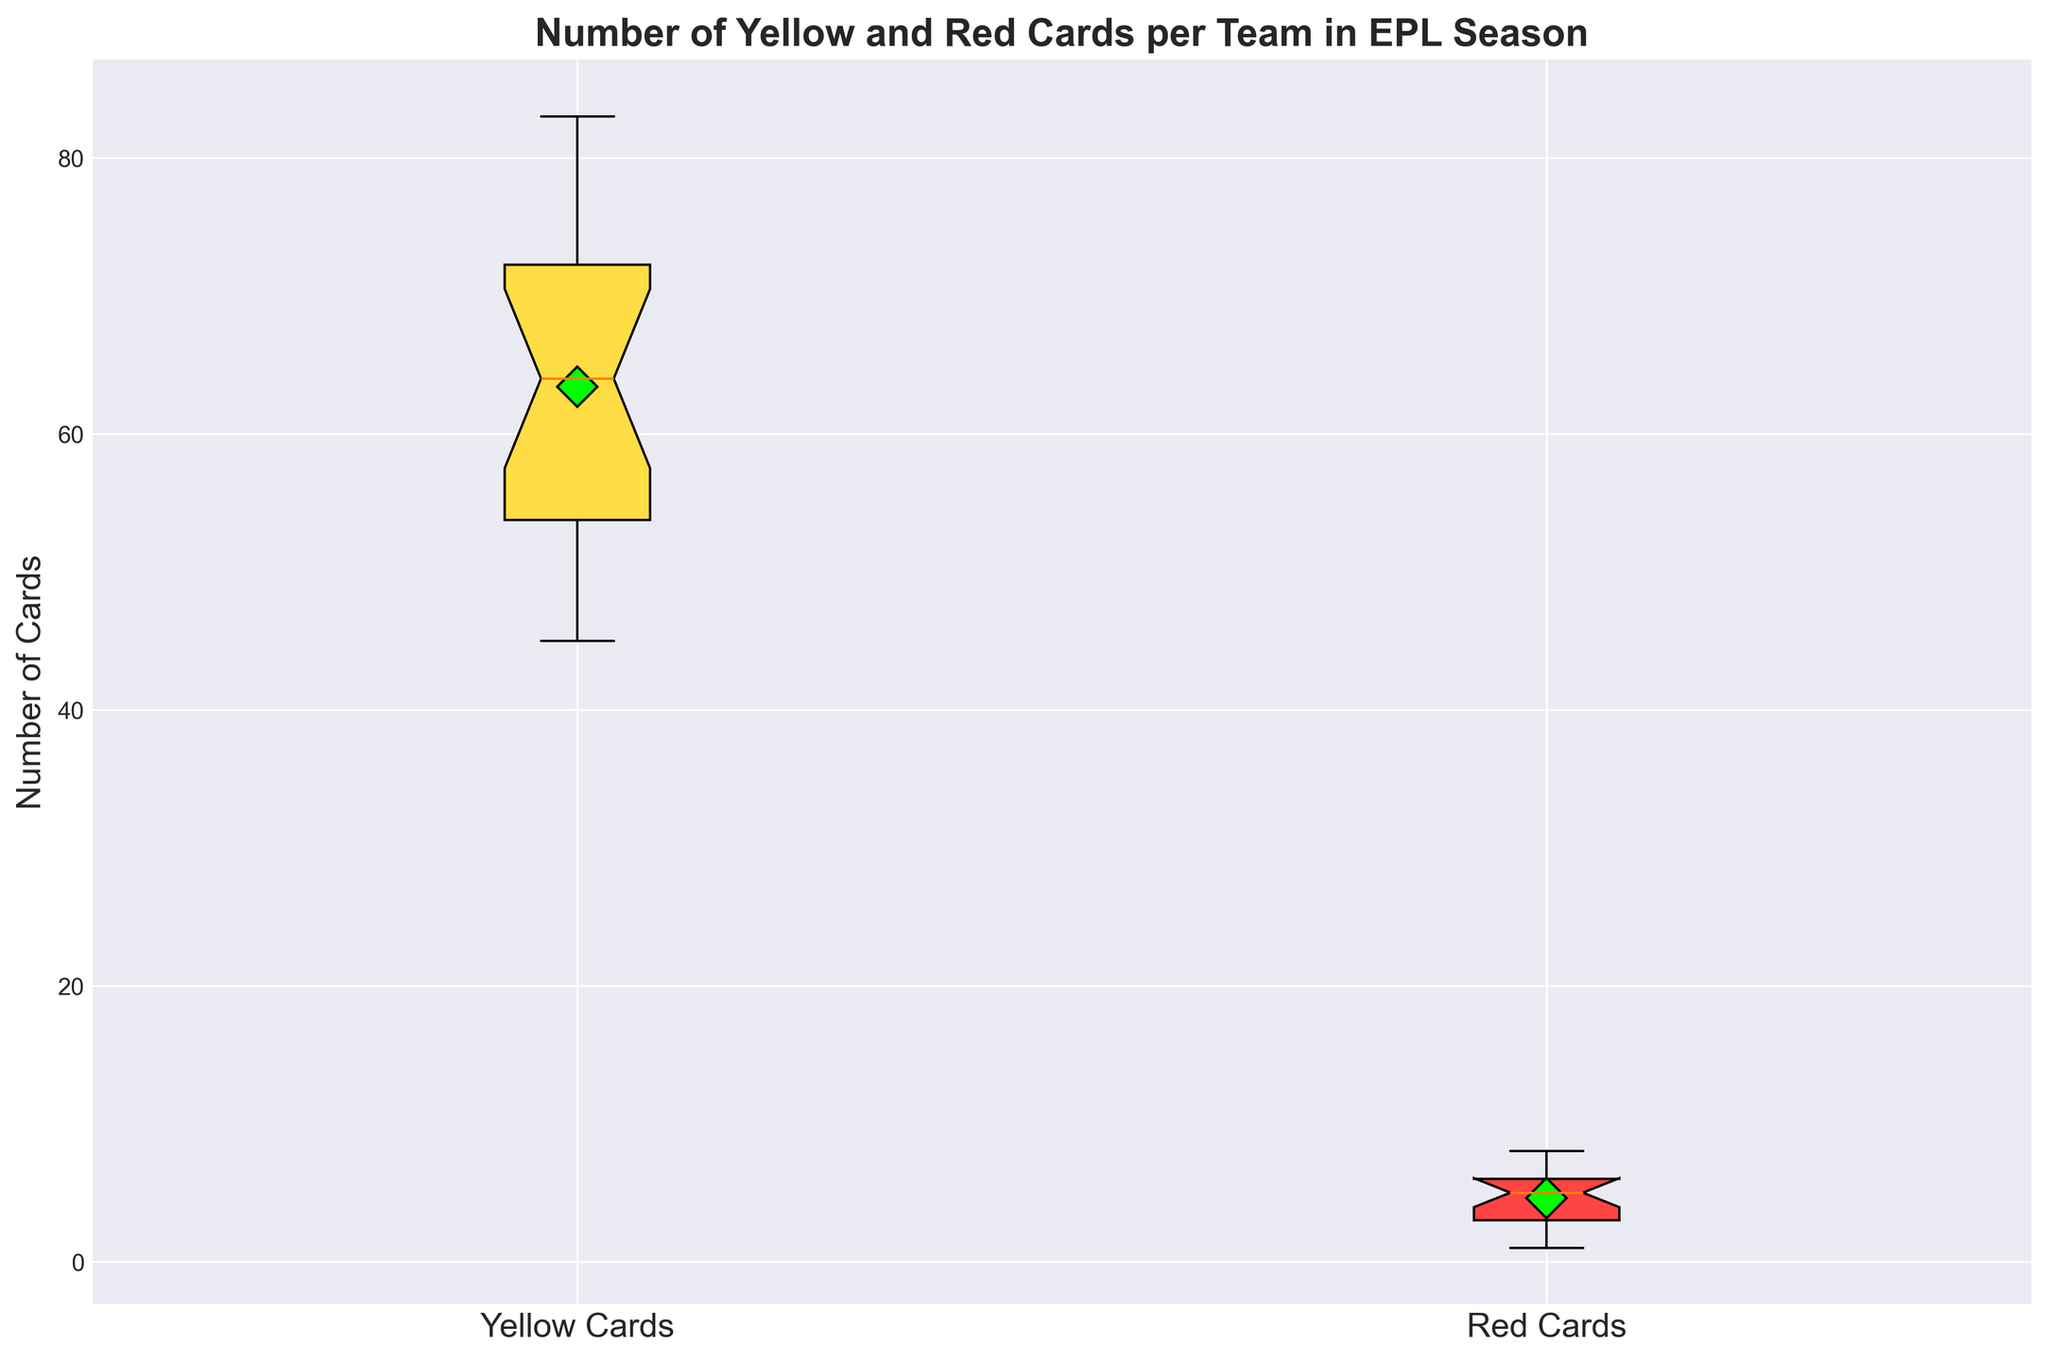什么球队的红牌数量最多？ 我们先看代表红牌数量的箱形图。注意到布伦特福德的数据点位于上须的最上端，代表它们的红牌数量最多。
Answer: 布伦特福德 黄色牌的中位数是多少？ 找到“Yellow Cards”箱形图中间的线，这条线代表中位数。
Answer: 61 红牌的范围是多少？ 红牌数量的范围是由其四分位数中的下鬚和上鬚表示的。它从数据集中最小值1到最大值8。
Answer: 1到8 平均每个队的黄牌数量是多少？ 平均黄牌数量表示为箱形图中的绿色菱形标记。查看“Yellow Cards”的箱形图，绿色菱形标记显示数字66左右。
Answer: 66 哪个球队的黄牌数量离群值最多？ 查找黄色牌箱形图中最远离箱子的点。注意到利兹联的数值猫出的点在箱形图的最上方。
Answer: 利兹联 什么球队的红牌数量最少？ 查找红牌箱形图中最远离箱子的下方的点。我们看到曼城是最小点。
Answer: 曼城 黄色牌的四分位间距是多少？ 四分位间距（IQR）是上四分位数(Q3)减去下四分位数(Q1)。从图中可以观察到黄色牌Q3大约是72，Q1大约是54。因此IQR=72-54=18。
Answer: 18 有多少个球队的黄牌数大于平均水平？ 先识别黄牌均值，然后数下多少球队的数值高于该标记。通过观察箱形图，上方有9个球队。
Answer: 9 红牌的中位数大约是多少？ 查找代表红牌的那条线在中间的位置。
Answer: 5 哪些球队的红牌数落在第三四分位数范围内？ 找到箱形图的上四分位数Q3和最大须线位置之间的标记，布伦特福德、南安普顿和狼队在这个范围内。
Answer: 布伦特福德、南安普顿、狼队 